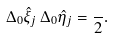<formula> <loc_0><loc_0><loc_500><loc_500>\Delta _ { 0 } \hat { \xi } _ { j } \, \Delta _ { 0 } \hat { \eta } _ { j } = \frac { } { 2 } .</formula> 